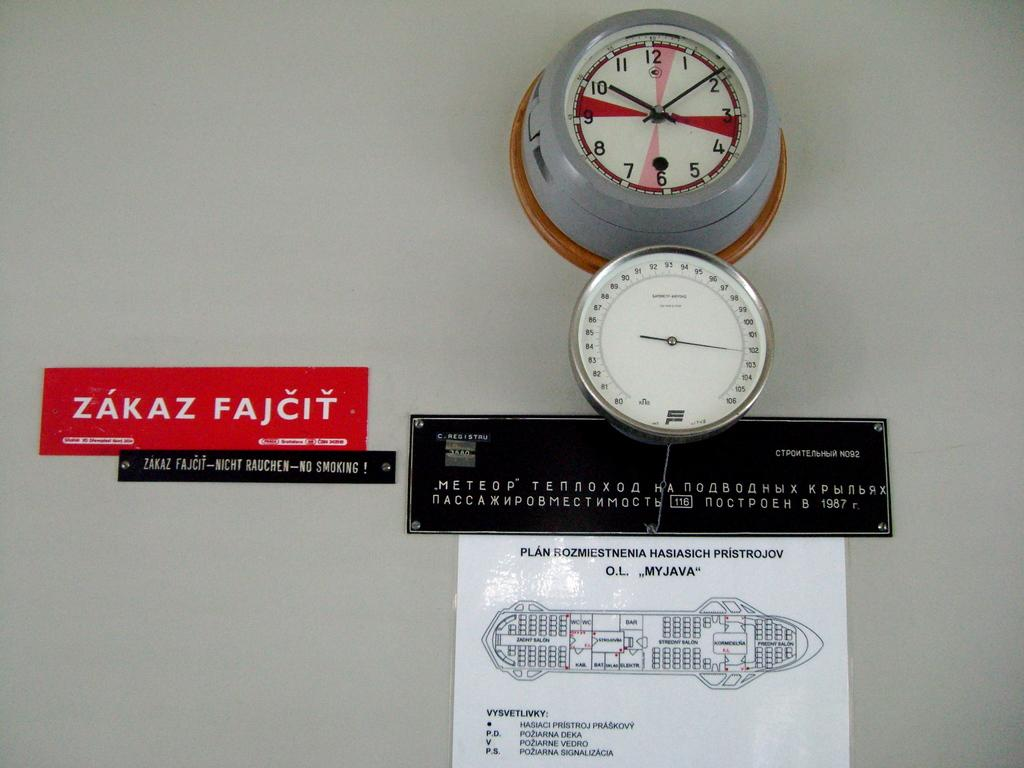<image>
Write a terse but informative summary of the picture. a zakaz sign that is on the wall 